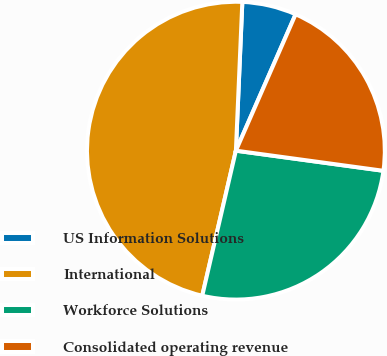Convert chart. <chart><loc_0><loc_0><loc_500><loc_500><pie_chart><fcel>US Information Solutions<fcel>International<fcel>Workforce Solutions<fcel>Consolidated operating revenue<nl><fcel>5.88%<fcel>47.06%<fcel>26.47%<fcel>20.59%<nl></chart> 